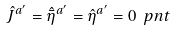<formula> <loc_0><loc_0><loc_500><loc_500>\hat { J } ^ { a ^ { \prime } } = \hat { \bar { \eta } } ^ { a ^ { \prime } } = \hat { \eta } ^ { a ^ { \prime } } = 0 \ p n t</formula> 